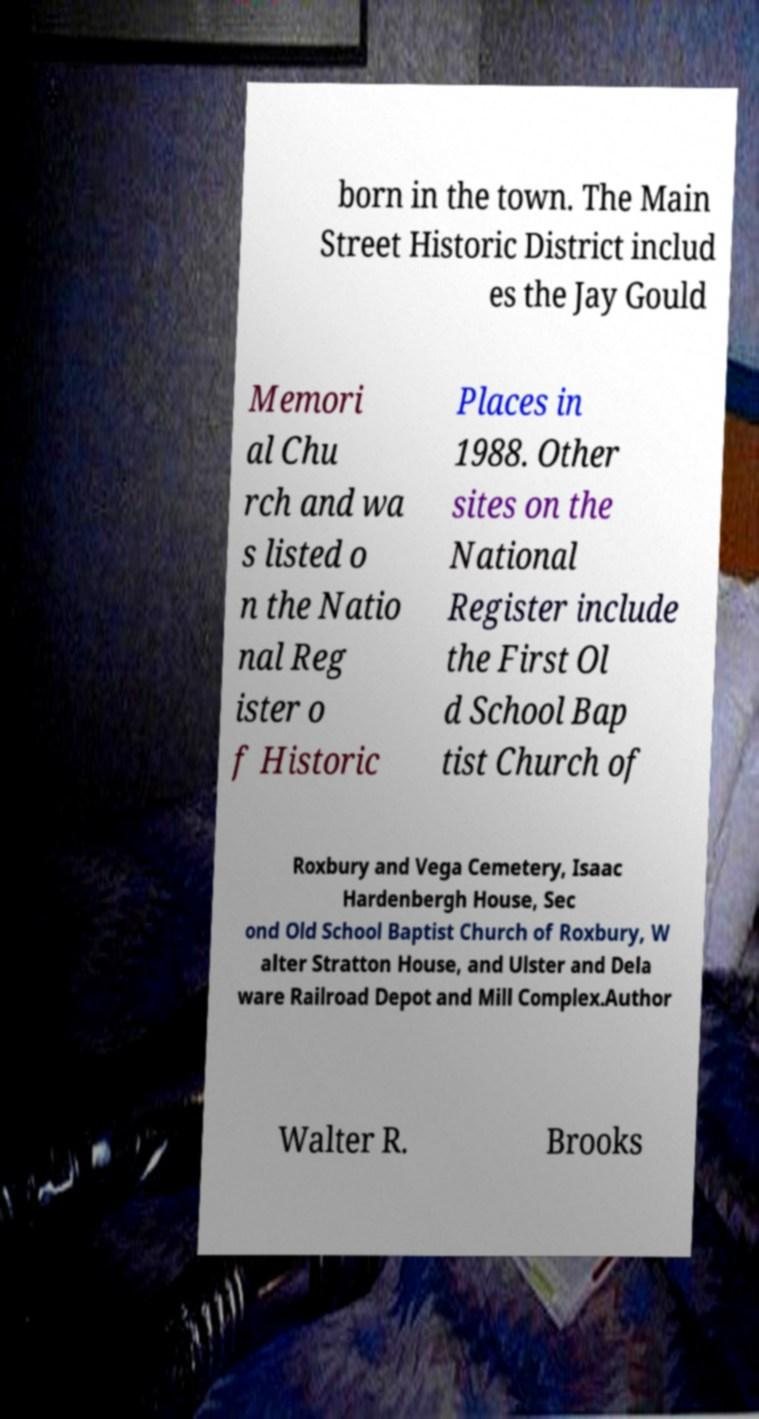Can you accurately transcribe the text from the provided image for me? born in the town. The Main Street Historic District includ es the Jay Gould Memori al Chu rch and wa s listed o n the Natio nal Reg ister o f Historic Places in 1988. Other sites on the National Register include the First Ol d School Bap tist Church of Roxbury and Vega Cemetery, Isaac Hardenbergh House, Sec ond Old School Baptist Church of Roxbury, W alter Stratton House, and Ulster and Dela ware Railroad Depot and Mill Complex.Author Walter R. Brooks 